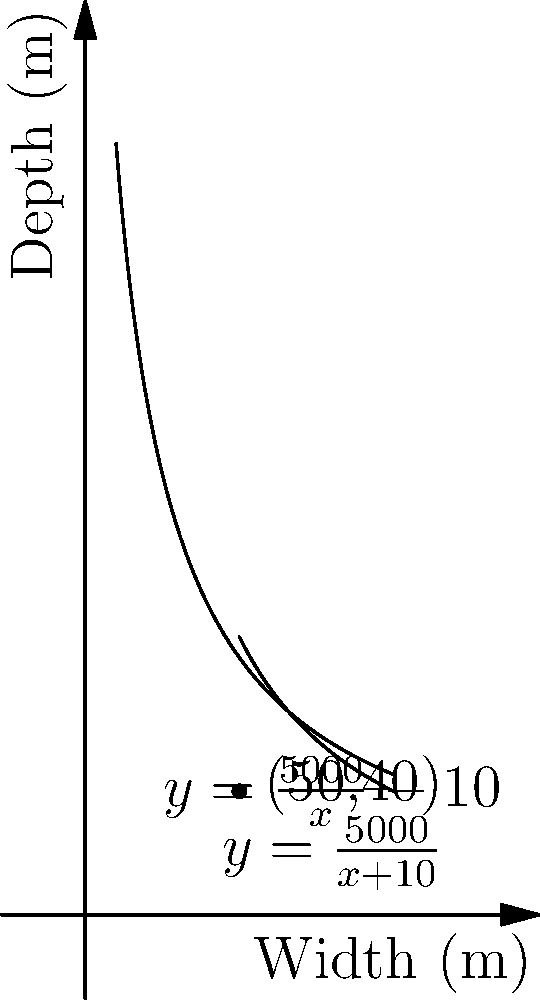A heavy metal band is planning their next big concert and wants to maximize the crowd capacity. The stage will be rectangular, and the venue requires that the total perimeter of the stage and crowd area be 300 meters. The crowd density is 2 people per square meter. If the stage depth must be 10 meters less than the crowd depth, what should be the dimensions of the crowd area to maximize capacity, and what is the maximum number of people that can attend? Let's approach this step-by-step:

1) Let $x$ be the width of the crowd area and $y$ be the depth of the crowd area.

2) The stage depth is $y - 10$ meters.

3) The perimeter constraint gives us:
   $2x + 2y + 2(y-10) = 300$
   $2x + 4y - 20 = 300$
   $2x + 4y = 320$
   $x + 2y = 160$ ... (1)

4) We want to maximize the area of the crowd:
   $A = xy$

5) From (1), we can express $x$ in terms of $y$:
   $x = 160 - 2y$

6) Substituting this into our area function:
   $A = y(160 - 2y) = 160y - 2y^2$

7) To find the maximum, we differentiate and set to zero:
   $\frac{dA}{dy} = 160 - 4y = 0$
   $160 = 4y$
   $y = 40$

8) The second derivative is negative ($-4$), confirming this is a maximum.

9) Substituting $y = 40$ back into equation (1):
   $x + 2(40) = 160$
   $x = 80$

10) Therefore, the crowd area should be 80m wide and 40m deep.

11) The stage will be 80m wide and 30m deep.

12) The maximum crowd capacity is:
    $80 * 40 * 2 = 6400$ people
Answer: Crowd area: 80m x 40m, Stage: 80m x 30m, Maximum capacity: 6400 people 